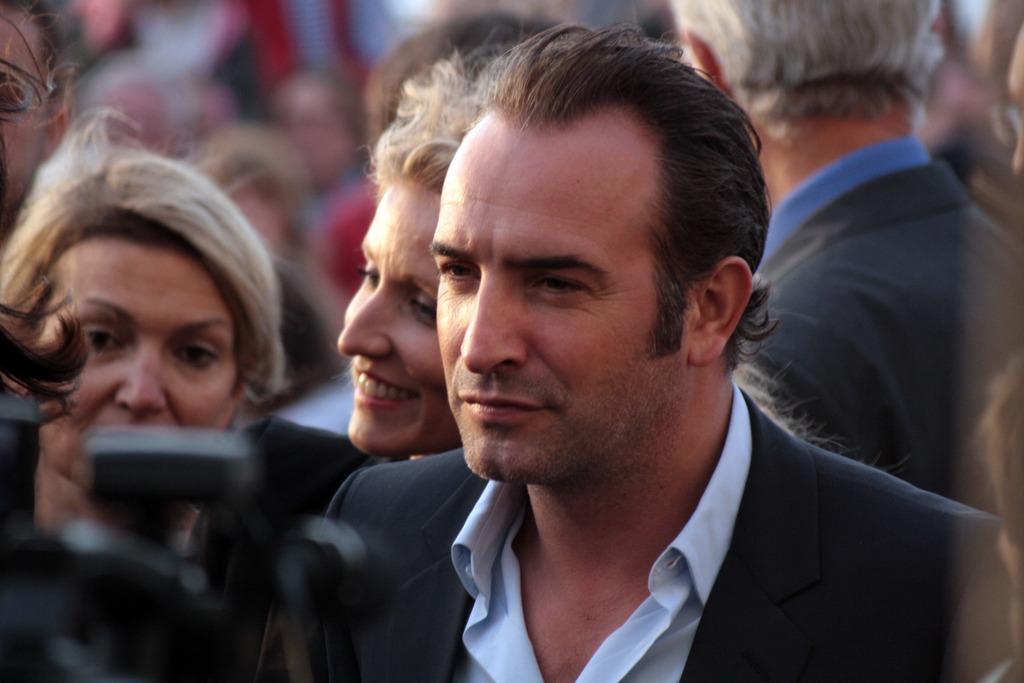In one or two sentences, can you explain what this image depicts? In front of the picture, we see the man in the white shirt and the black blazer is standing. Beside him, we see two women are standing and they are smiling. Behind him, we see a man is standing. In the background, we see many people. In the left bottom, we see an object in black color. This picture is blurred in the background. 